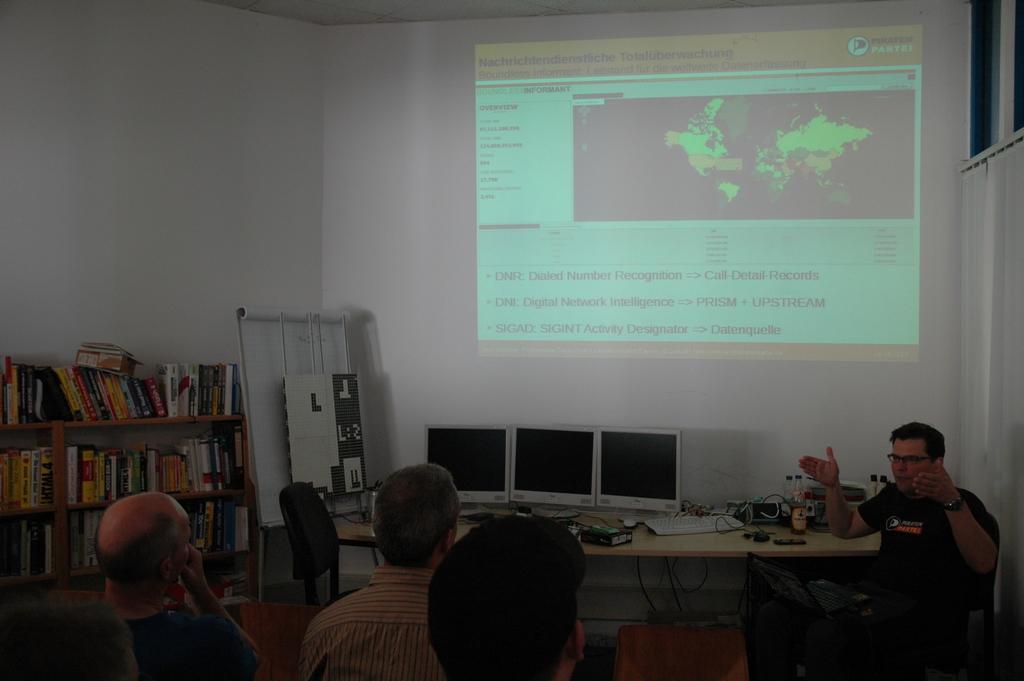Can you describe this image briefly? At the bottom of the image we can see persons and books placed placed in shelves. On the right side of the image we can see persons sitting at the table. On the table we can see computers, keyboard and some objects placed on the table. In the background we can see wall. 